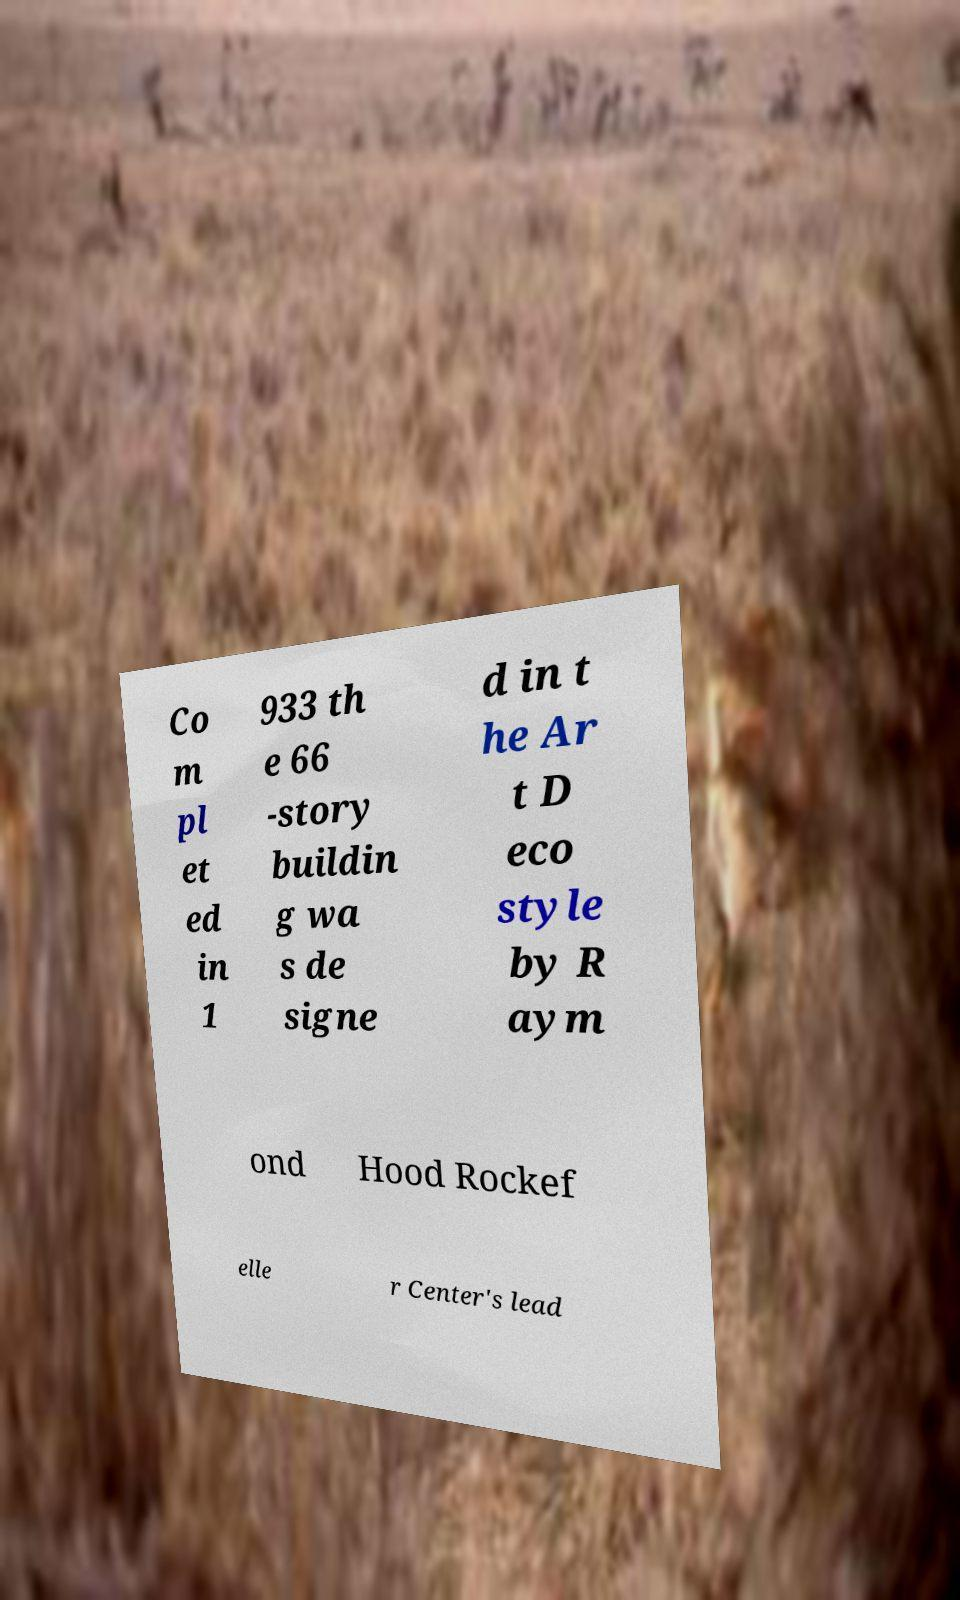Please read and relay the text visible in this image. What does it say? Co m pl et ed in 1 933 th e 66 -story buildin g wa s de signe d in t he Ar t D eco style by R aym ond Hood Rockef elle r Center's lead 